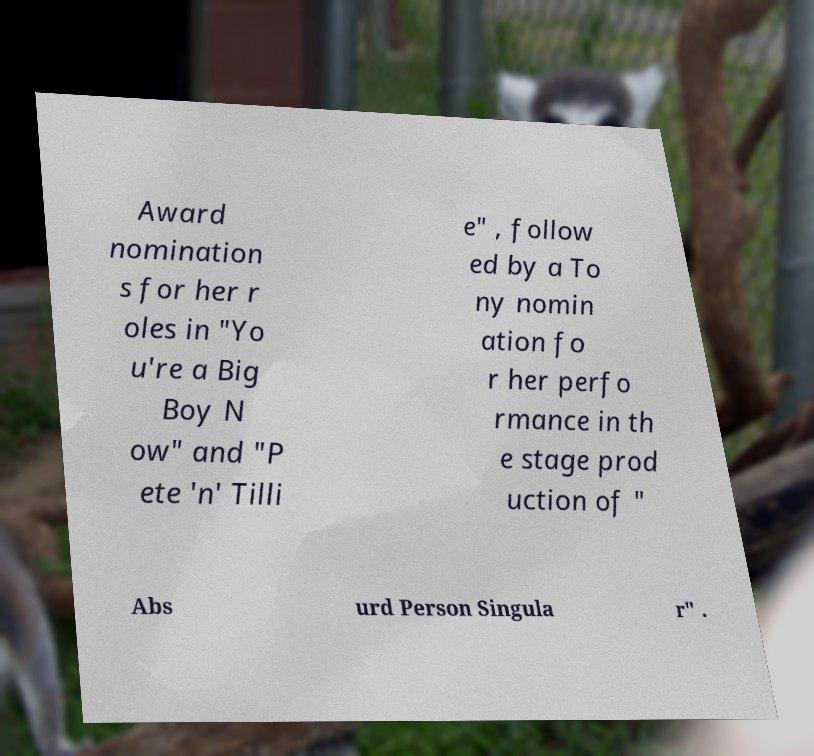Could you assist in decoding the text presented in this image and type it out clearly? Award nomination s for her r oles in "Yo u're a Big Boy N ow" and "P ete 'n' Tilli e" , follow ed by a To ny nomin ation fo r her perfo rmance in th e stage prod uction of " Abs urd Person Singula r" . 